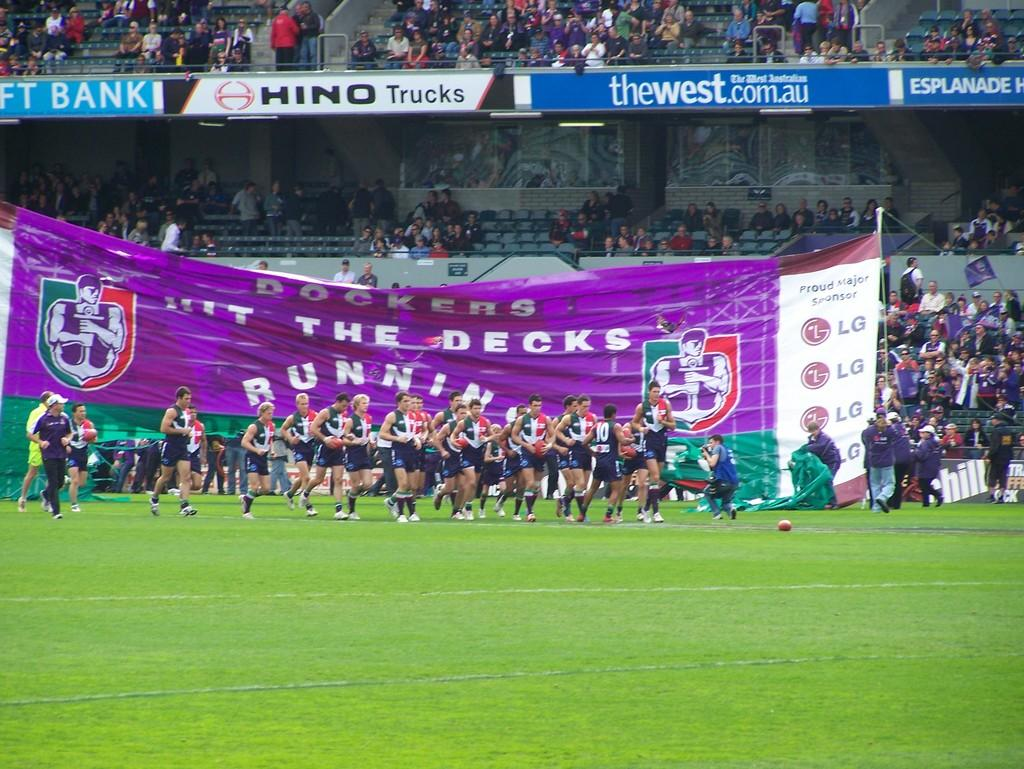Provide a one-sentence caption for the provided image. Sports venue with a large purple banner marked Dockers Hit the decks running. 